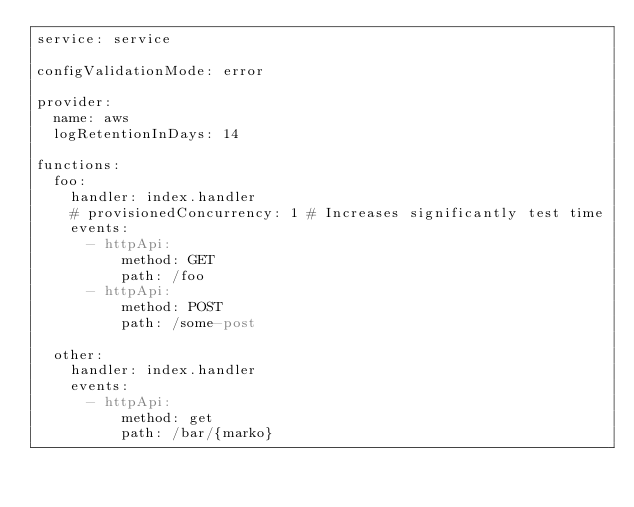<code> <loc_0><loc_0><loc_500><loc_500><_YAML_>service: service

configValidationMode: error

provider:
  name: aws
  logRetentionInDays: 14

functions:
  foo:
    handler: index.handler
    # provisionedConcurrency: 1 # Increases significantly test time
    events:
      - httpApi:
          method: GET
          path: /foo
      - httpApi:
          method: POST
          path: /some-post

  other:
    handler: index.handler
    events:
      - httpApi:
          method: get
          path: /bar/{marko}
</code> 